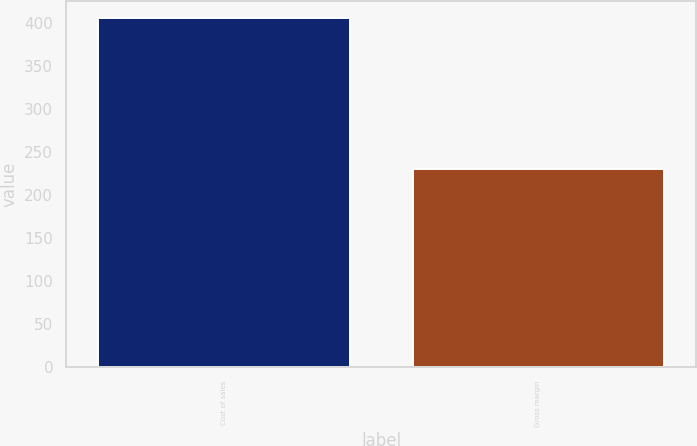Convert chart to OTSL. <chart><loc_0><loc_0><loc_500><loc_500><bar_chart><fcel>Cost of sales<fcel>Gross margin<nl><fcel>405<fcel>230<nl></chart> 